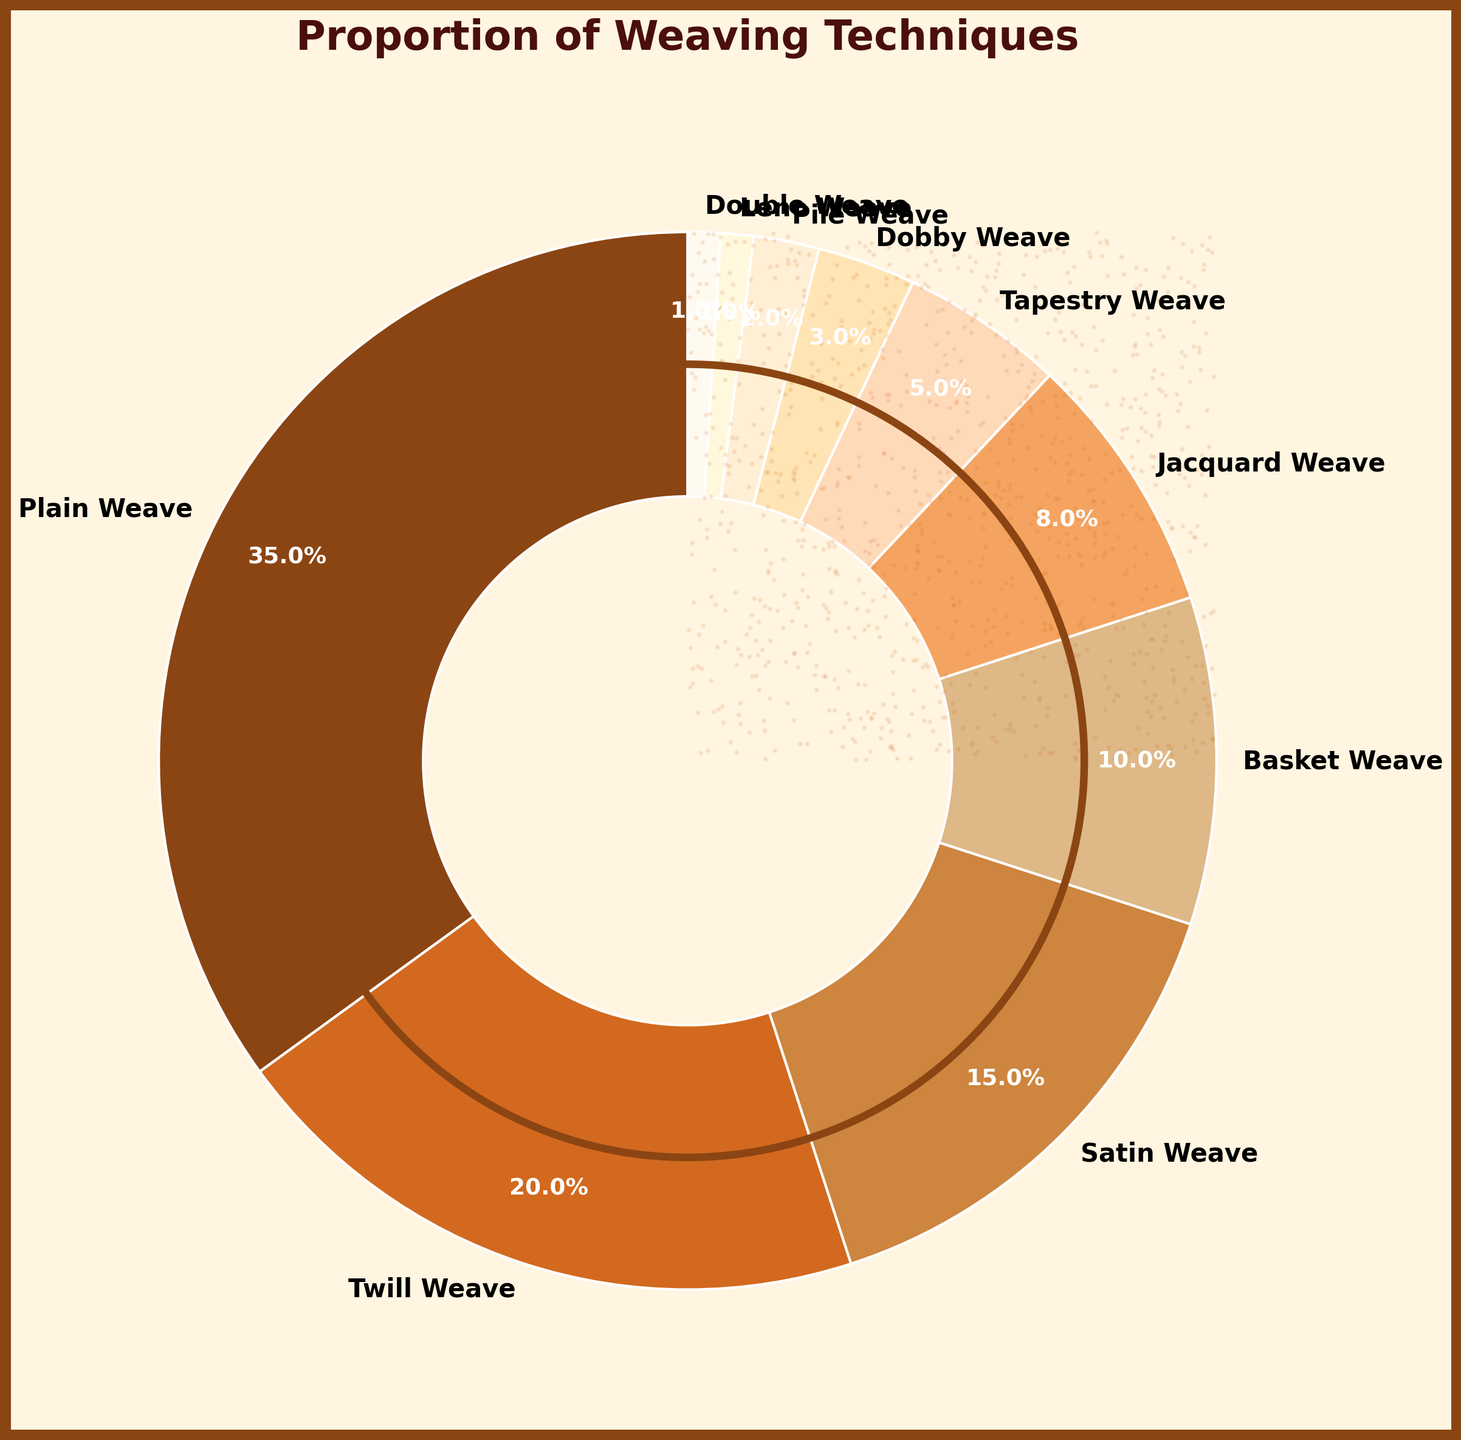What technique holds the largest percentage? The largest section on the pie chart represents the technique with the highest percentage. By visually inspecting the pie chart, we can see that "Plain Weave" has the largest section.
Answer: Plain Weave Which two techniques combined account for more than half of the total percentage? To determine this, we add the percentages of the two largest techniques: Plain Weave (35%) + Twill Weave (20%) = 55%. This sum exceeds 50%.
Answer: Plain Weave and Twill Weave Out of Basket Weave and Jacquard Weave, which technique occupies a larger proportion on the chart? By comparing the two sections visually, we see that Basket Weave (10%) has a larger slice compared to Jacquard Weave (8%).
Answer: Basket Weave What is the total percentage of the three least common techniques? Adding the percentages of Dobby Weave (3%), Pile Weave (2%), and Leno Weave (1%), we get 3% + 2% + 1% = 6%.
Answer: 6% Which technique has a representation closest to 10% on the chart? By examining the chart, we see that Basket Weave has a percentage of 10%, which is closest to the value mentioned.
Answer: Basket Weave Is the combined proportion of Satin Weave and Tapestry Weave less than the proportion of Plain Weave? Adding the percentages: Satin Weave (15%) + Tapestry Weave (5%) = 20%. This is less than Plain Weave, which is 35%.
Answer: Yes Between Dobby Weave and Pile Weave, which technique accounts for a lesser percentage? Looking at the pie chart, the section for Pile Weave (2%) is smaller than that for Dobby Weave (3%).
Answer: Pile Weave Is there any technique that holds exactly 1% of the total percentage? Inspecting the chart reveals that both Leno Weave and Double Weave have a 1% representation.
Answer: Yes, both Leno Weave and Double Weave How much more percentage does Plain Weave have than Satin Weave? Subtract the percentage of Satin Weave (15%) from that of Plain Weave (35%): 35% - 15% = 20%.
Answer: 20% If you combine the percentages of Twill Weave and Jacquard Weave, do these two techniques collectively hold more than the percentage of Plain Weave alone? Adding the two percentages: Twill Weave (20%) + Jacquard Weave (8%) = 28%. This is still less than the 35% held by Plain Weave.
Answer: No 